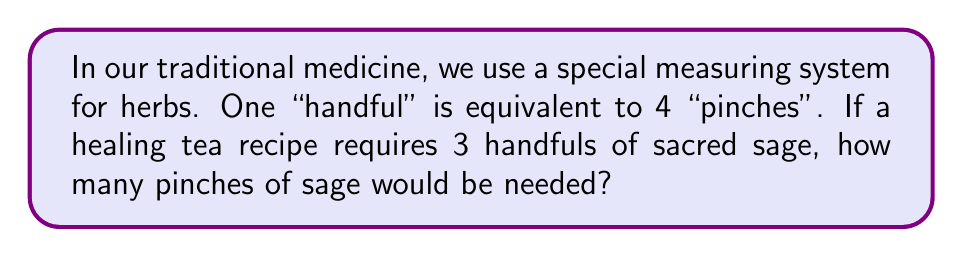Could you help me with this problem? Let's approach this step-by-step:

1. Understand the given information:
   - 1 handful = 4 pinches
   - The recipe requires 3 handfuls

2. Set up the conversion:
   $$3 \text{ handfuls} \times \frac{4 \text{ pinches}}{1 \text{ handful}} = x \text{ pinches}$$

3. Perform the multiplication:
   $$3 \times 4 = 12$$

Therefore, 3 handfuls of sacred sage is equivalent to 12 pinches.
Answer: 12 pinches 